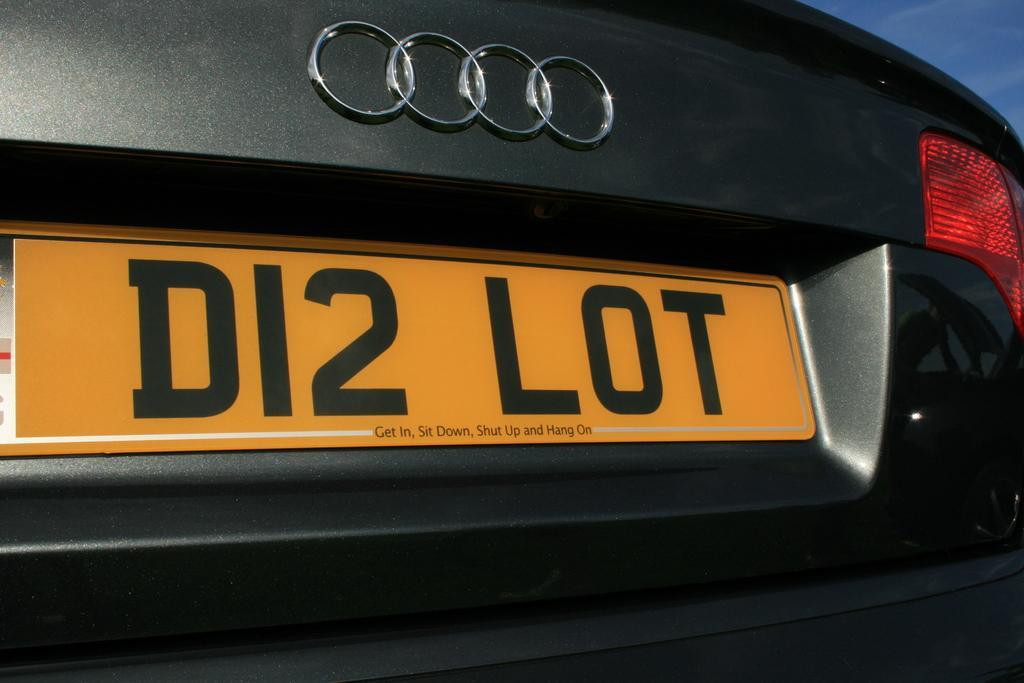Can you describe this image briefly? In the picture I can see a black color car. On the car I can see a logo and a number plate. On the number plate I can see something written on it. The number plate is yellow in color. 